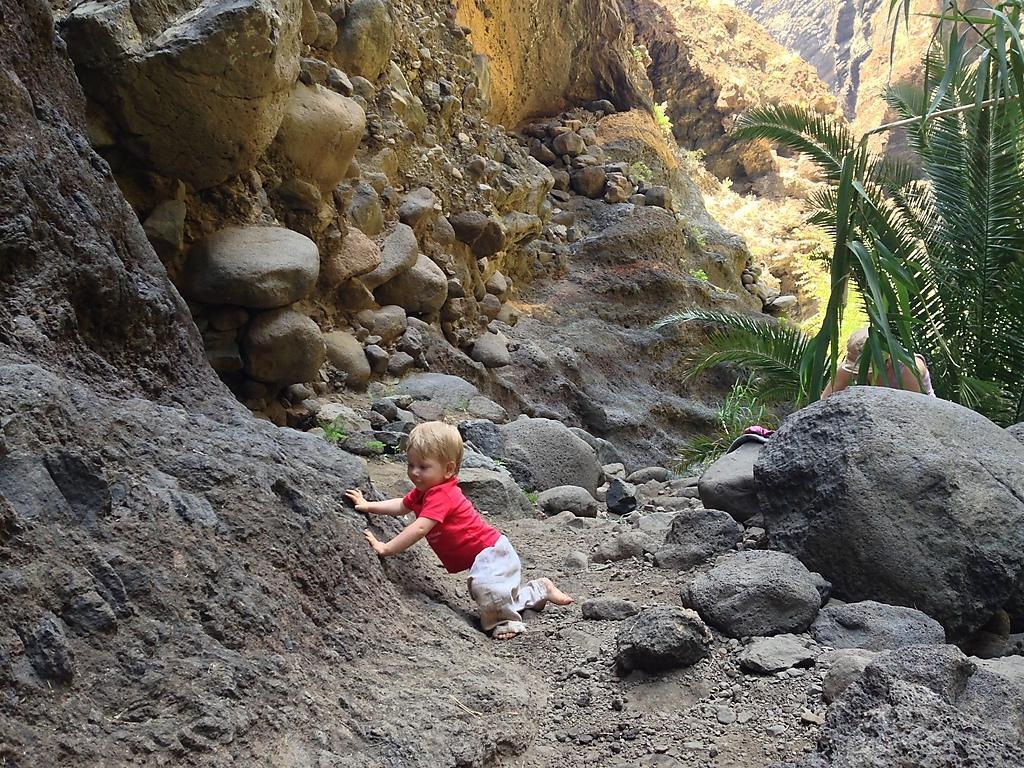Can you describe this image briefly? In this picture we can see a boy on the sand, around we can see rocks, trees and sand. 